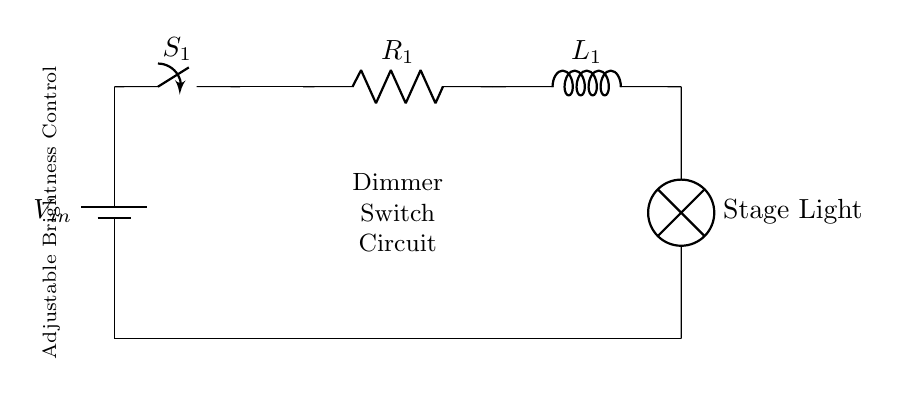What is the input voltage of the circuit? The circuit diagram shows a battery labeled as V_in connected at the top, which indicates the input voltage for the circuit.
Answer: V_in What component adjusts the brightness of the stage light? The circuit includes a switch labeled S_1, which can control the current flow and thereby adjust the brightness of the stage light when toggled.
Answer: Switch What are the two main components used in the circuit? The diagram features a resistor labeled R_1 and an inductor labeled L_1, which are essential components in the dimmer switch circuit.
Answer: Resistor and inductor How are the components connected in the circuit? Observing the diagram, the components (battery, switch, resistor, inductor, and lamp) are connected in series, indicating a sequential arrangement where the current flows through each component one after another.
Answer: Series connection What does the lamp represent in the circuit? The lamp in the circuit is labeled as "Stage Light," indicating that it represents the actual lighting used in a stage setup, which is illuminated based on the controlled circuit.
Answer: Stage light How does the inductor influence the circuit? Inductors like L_1 in the circuit oppose changes in current flow due to their inductive properties, which can help in smoothing out the voltage and current changes, leading to a more stable light output.
Answer: Smooth voltage What is the role of the switch in this circuit? The switch S_1 serves as a control mechanism to either open or close the circuit, allowing or stopping the flow of electrical current, which directly affects the operation of the dimmer and thus the brightness of the connected stage light.
Answer: Control current flow 